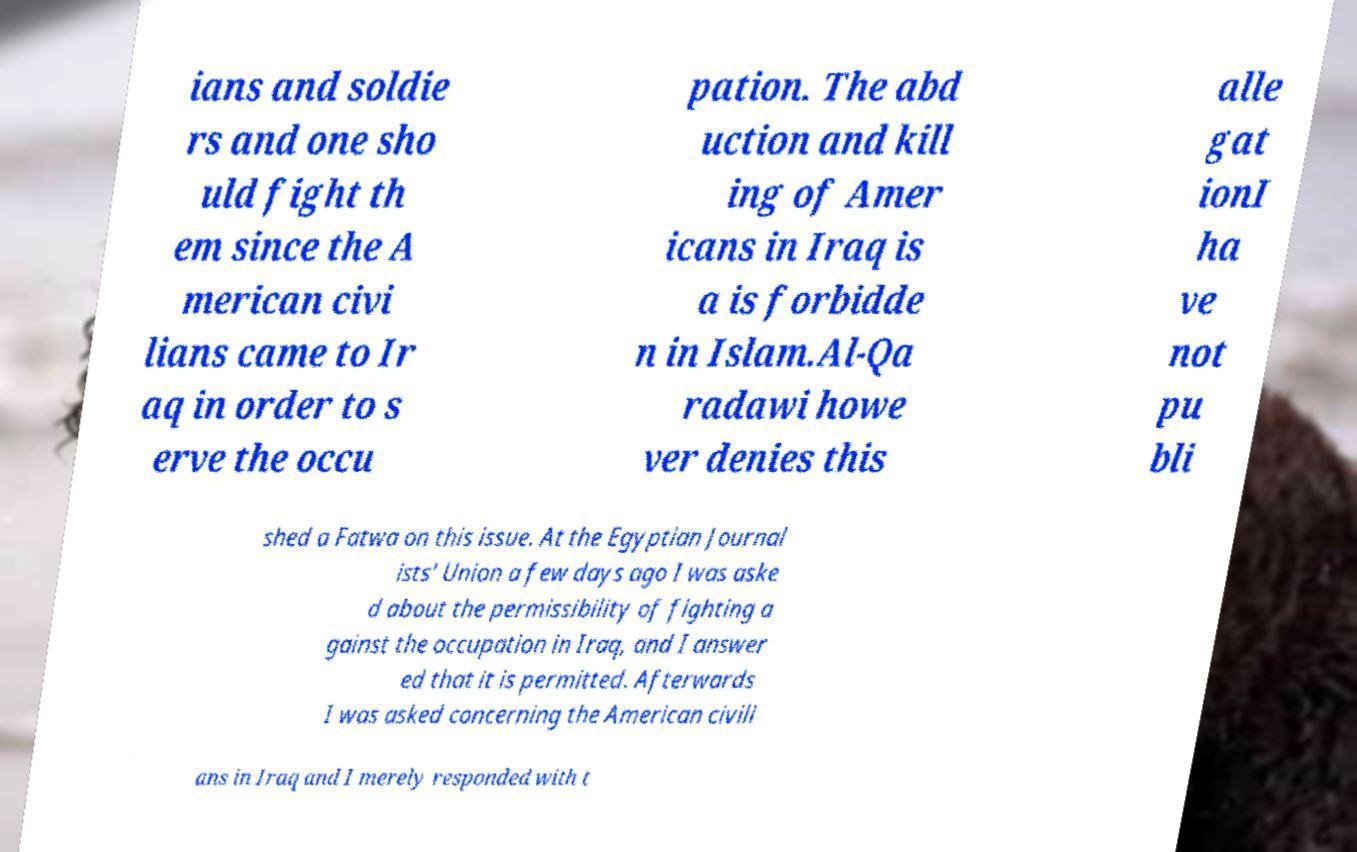Please identify and transcribe the text found in this image. ians and soldie rs and one sho uld fight th em since the A merican civi lians came to Ir aq in order to s erve the occu pation. The abd uction and kill ing of Amer icans in Iraq is a is forbidde n in Islam.Al-Qa radawi howe ver denies this alle gat ionI ha ve not pu bli shed a Fatwa on this issue. At the Egyptian Journal ists' Union a few days ago I was aske d about the permissibility of fighting a gainst the occupation in Iraq, and I answer ed that it is permitted. Afterwards I was asked concerning the American civili ans in Iraq and I merely responded with t 